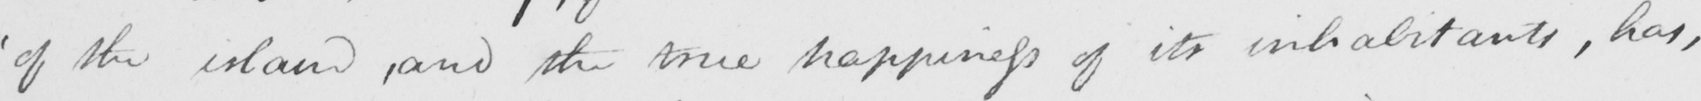Please transcribe the handwritten text in this image. ' of the island , and the true happiness of its inhabitants , has , 